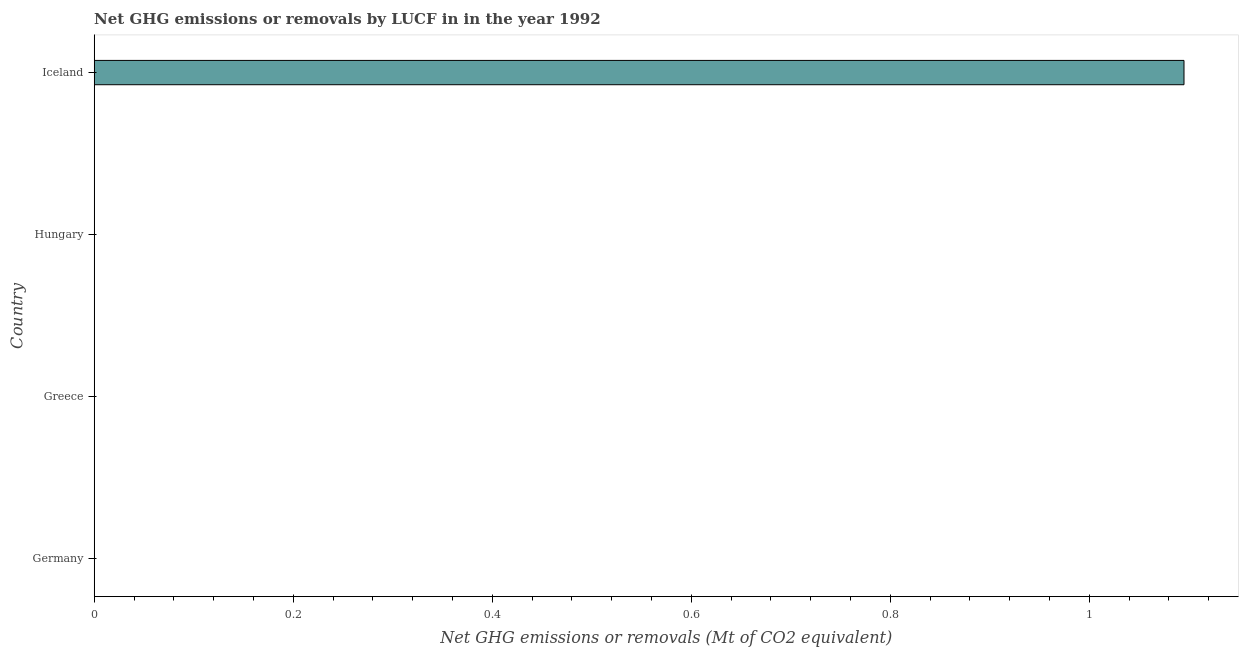Does the graph contain grids?
Offer a terse response. No. What is the title of the graph?
Provide a succinct answer. Net GHG emissions or removals by LUCF in in the year 1992. What is the label or title of the X-axis?
Your response must be concise. Net GHG emissions or removals (Mt of CO2 equivalent). What is the label or title of the Y-axis?
Ensure brevity in your answer.  Country. What is the ghg net emissions or removals in Hungary?
Offer a terse response. 0. Across all countries, what is the maximum ghg net emissions or removals?
Make the answer very short. 1.1. What is the sum of the ghg net emissions or removals?
Keep it short and to the point. 1.1. What is the average ghg net emissions or removals per country?
Your response must be concise. 0.27. In how many countries, is the ghg net emissions or removals greater than 0.48 Mt?
Offer a terse response. 1. In how many countries, is the ghg net emissions or removals greater than the average ghg net emissions or removals taken over all countries?
Give a very brief answer. 1. How many bars are there?
Give a very brief answer. 1. Are all the bars in the graph horizontal?
Your response must be concise. Yes. How many countries are there in the graph?
Ensure brevity in your answer.  4. What is the difference between two consecutive major ticks on the X-axis?
Make the answer very short. 0.2. Are the values on the major ticks of X-axis written in scientific E-notation?
Provide a succinct answer. No. What is the Net GHG emissions or removals (Mt of CO2 equivalent) in Germany?
Provide a succinct answer. 0. What is the Net GHG emissions or removals (Mt of CO2 equivalent) of Hungary?
Offer a very short reply. 0. What is the Net GHG emissions or removals (Mt of CO2 equivalent) in Iceland?
Provide a succinct answer. 1.1. 